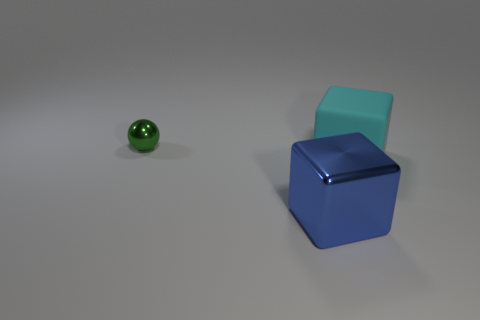Is there another cyan cube that has the same material as the big cyan block?
Give a very brief answer. No. There is another large object that is the same shape as the big shiny object; what color is it?
Offer a terse response. Cyan. Are there fewer big cyan rubber cubes that are behind the tiny green thing than small shiny balls on the right side of the rubber thing?
Your answer should be very brief. No. What number of other things are the same shape as the cyan rubber object?
Ensure brevity in your answer.  1. Are there fewer big blue metal blocks that are on the right side of the rubber thing than small blue metallic things?
Provide a succinct answer. No. There is a large cube to the right of the large blue thing; what is it made of?
Your answer should be very brief. Rubber. What number of other objects are there of the same size as the green sphere?
Your answer should be very brief. 0. Are there fewer large cyan rubber things than small yellow matte cylinders?
Offer a terse response. No. What is the shape of the small green metallic object?
Ensure brevity in your answer.  Sphere. Do the metal thing that is behind the big blue shiny thing and the matte object have the same color?
Provide a succinct answer. No. 